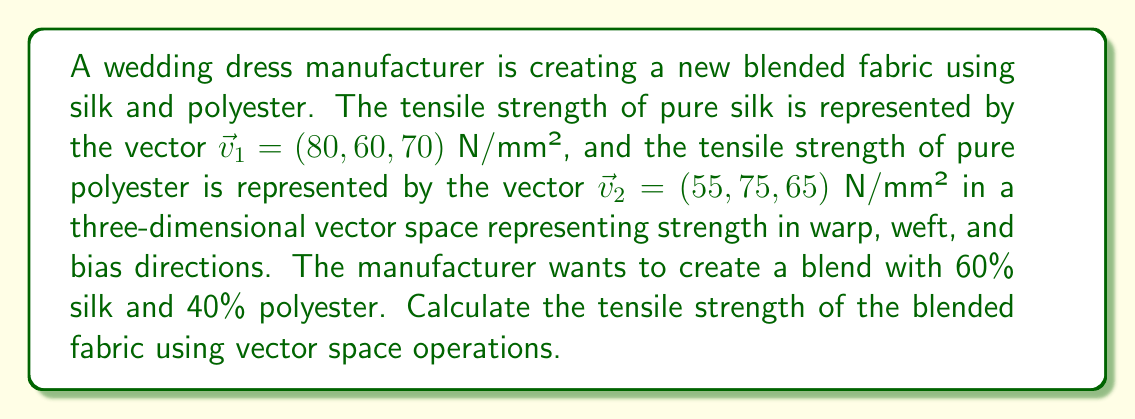Can you answer this question? To solve this problem, we'll use the properties of vector spaces and linear combinations:

1) First, we need to represent the blended fabric as a linear combination of the two base fabrics:
   $$v_{blend} = 0.6v_1 + 0.4v_2$$

2) Now, let's calculate each component:
   
   For silk (60%):
   $$0.6v_1 = 0.6(80, 60, 70) = (48, 36, 42)$$
   
   For polyester (40%):
   $$0.4v_2 = 0.4(55, 75, 65) = (22, 30, 26)$$

3) To get the final tensile strength, we add these vectors:
   $$v_{blend} = (48, 36, 42) + (22, 30, 26)$$

4) Performing the vector addition:
   $$v_{blend} = (48+22, 36+30, 42+26) = (70, 66, 68)$$

Therefore, the tensile strength of the blended fabric is represented by the vector $(70, 66, 68)$ N/mm².
Answer: The tensile strength of the blended fabric is $(70, 66, 68)$ N/mm², where the components represent the strength in the warp, weft, and bias directions respectively. 